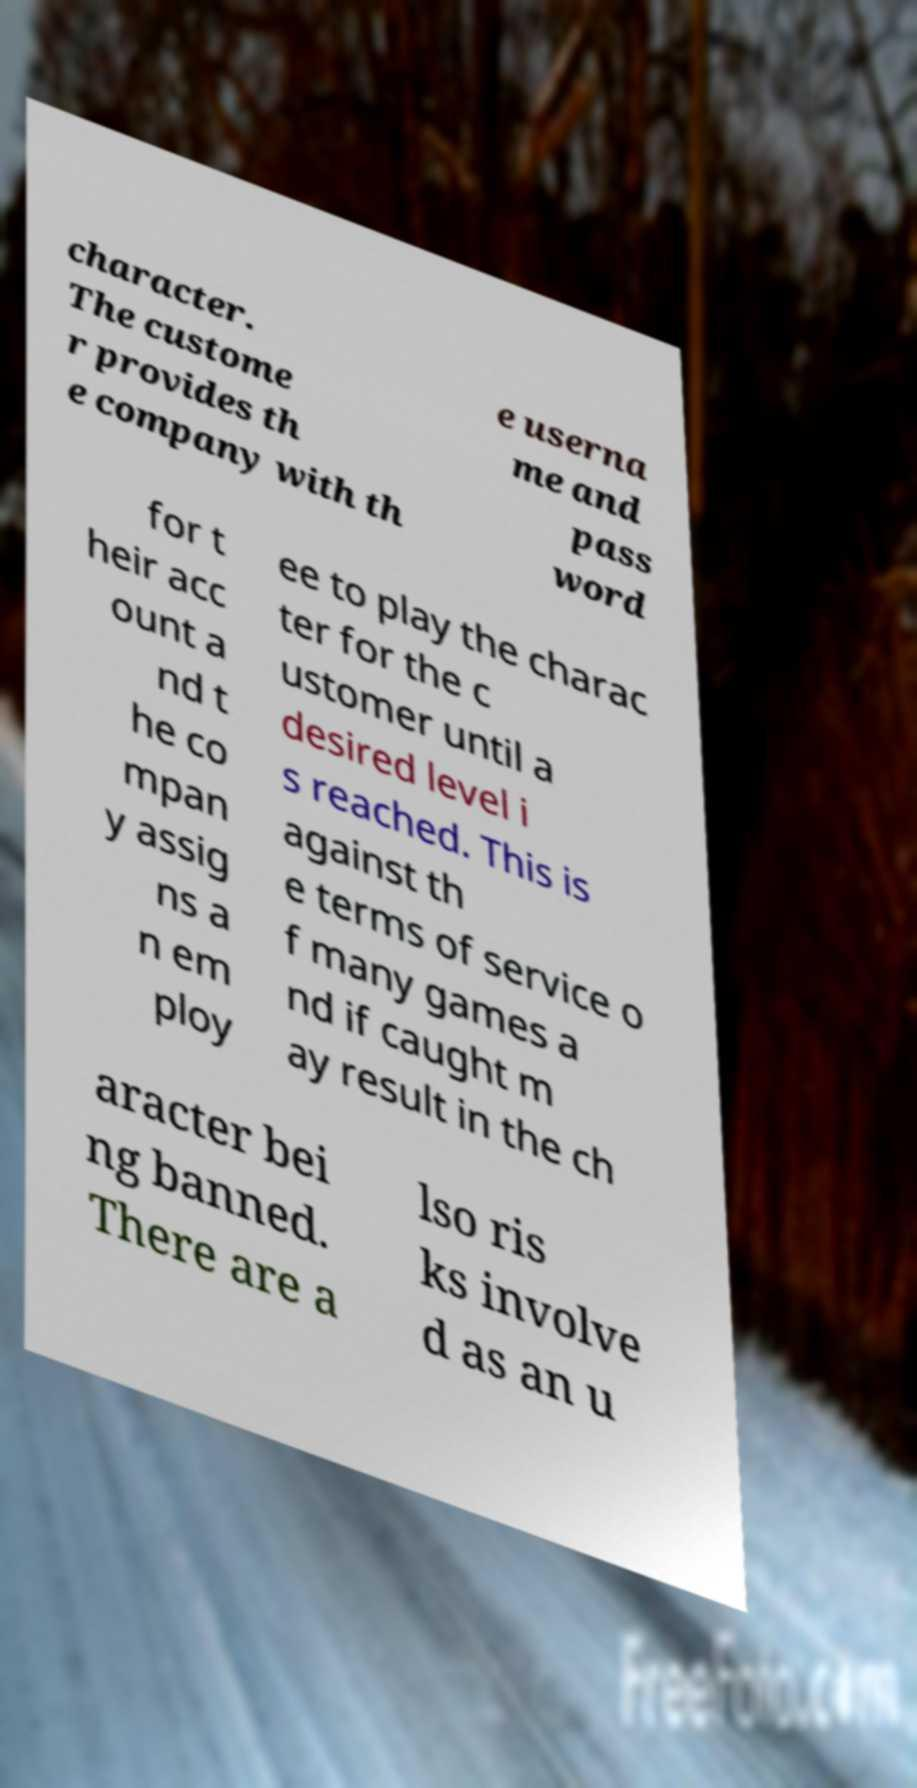Please identify and transcribe the text found in this image. character. The custome r provides th e company with th e userna me and pass word for t heir acc ount a nd t he co mpan y assig ns a n em ploy ee to play the charac ter for the c ustomer until a desired level i s reached. This is against th e terms of service o f many games a nd if caught m ay result in the ch aracter bei ng banned. There are a lso ris ks involve d as an u 